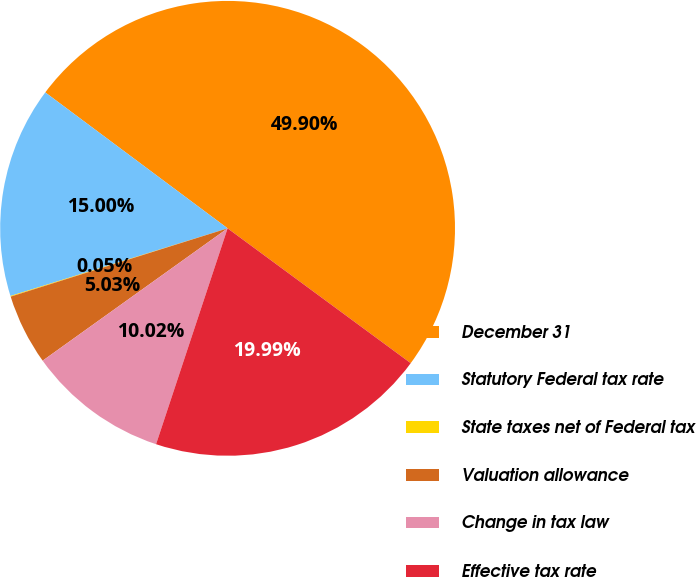Convert chart to OTSL. <chart><loc_0><loc_0><loc_500><loc_500><pie_chart><fcel>December 31<fcel>Statutory Federal tax rate<fcel>State taxes net of Federal tax<fcel>Valuation allowance<fcel>Change in tax law<fcel>Effective tax rate<nl><fcel>49.9%<fcel>15.0%<fcel>0.05%<fcel>5.03%<fcel>10.02%<fcel>19.99%<nl></chart> 